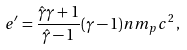Convert formula to latex. <formula><loc_0><loc_0><loc_500><loc_500>e ^ { \prime } = \frac { \hat { \gamma } \gamma + 1 } { \hat { \gamma } - 1 } ( \gamma - 1 ) n m _ { p } c ^ { 2 } \, ,</formula> 